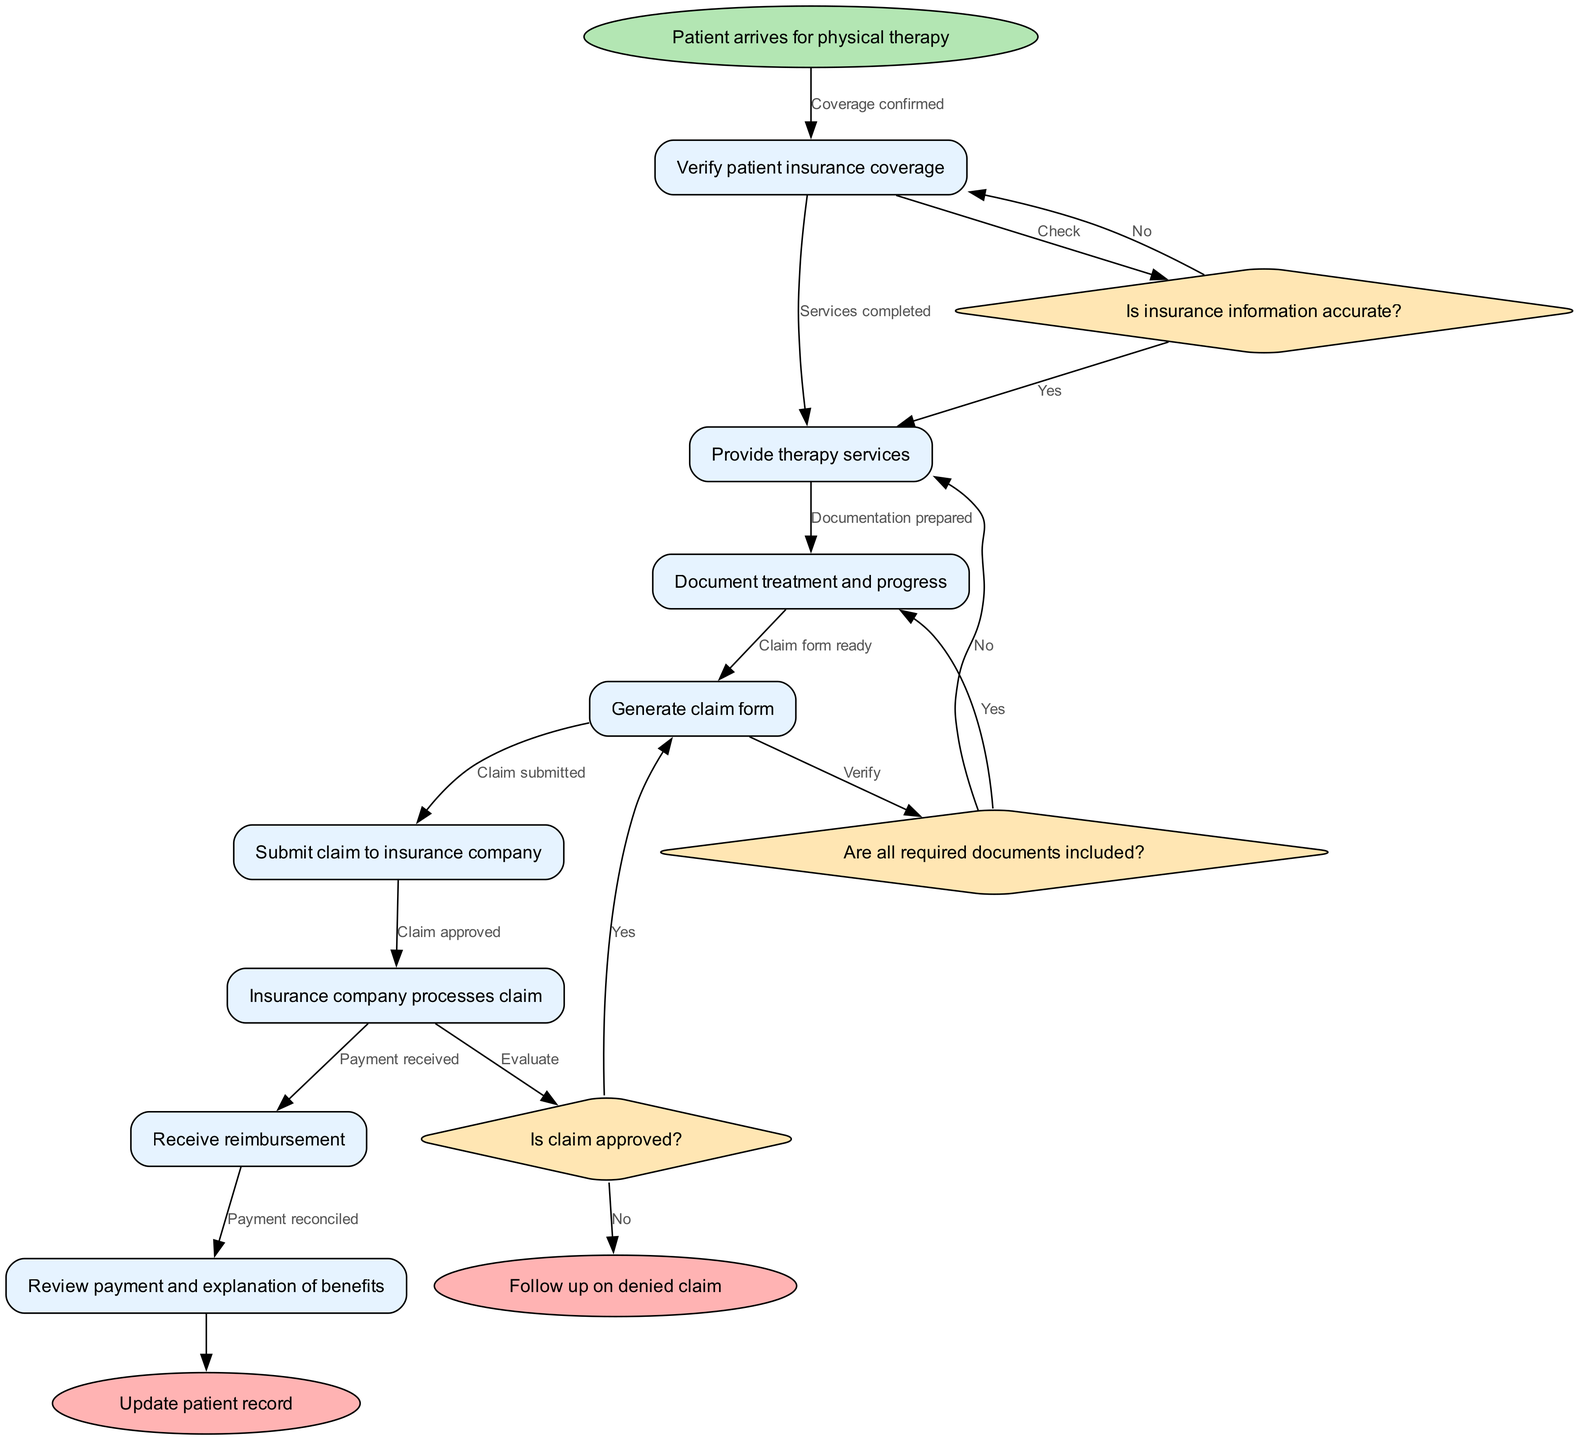What is the starting point of the claim submission process? The process begins at the "Patient arrives for physical therapy" node, which is clearly marked as the start point.
Answer: Patient arrives for physical therapy How many decision nodes are there in the flowchart? There are three decision nodes: “Is insurance information accurate?”, “Are all required documents included?”, and “Is claim approved?” Counting these gives a total of three decision nodes.
Answer: 3 What happens if the insurance information is not accurate? Following the flowchart, if the insurance information is not accurate, the process directs to the "No" branch from the first decision node, which effectively does not lead to any further processed steps towards submission.
Answer: No further processing Which node follows after the claim form is generated? After generating the claim form, the next node is "Submit claim to insurance company," indicating that the next step is to submit the generated claim.
Answer: Submit claim to insurance company At which point do we receive reimbursement? Reimbursement is received after the insurance company processes the claim, which is documented in the flowchart as "Receive reimbursement," following the decision node for claim approval.
Answer: Receive reimbursement How many end nodes are present in the diagram? There are two end nodes: "Update patient record" and "Follow up on denied claim," indicating the conclusion points of the process. Therefore, the total number of end nodes is two.
Answer: 2 What is the condition checked before processing the claim? The condition checked is "Is claim approved?" This decision node evaluates whether the claim can proceed to the reimbursement stage based on approval status.
Answer: Is claim approved? If all required documents are included, what is the next step? If all required documents are included, the flowchart indicates a 'Yes' response that proceeds to the next node, which is "Insurance company processes claim."
Answer: Insurance company processes claim 